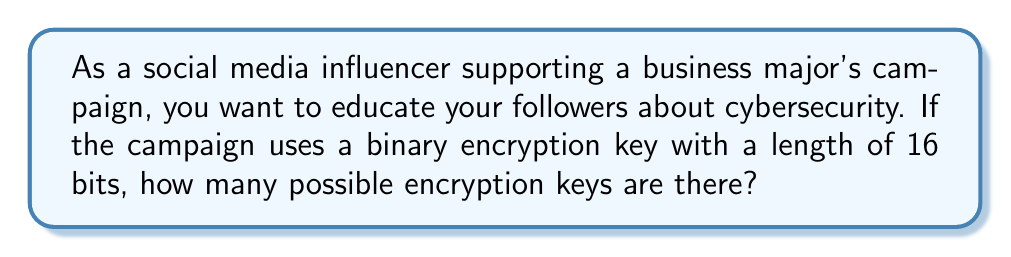Show me your answer to this math problem. To determine the number of possible encryption keys for a given key length, we need to follow these steps:

1. Identify the key length: In this case, it's 16 bits.

2. Understand the possible values for each bit: In binary, each bit can be either 0 or 1.

3. Calculate the total number of possibilities:
   - For each bit, there are 2 choices (0 or 1)
   - We have 16 bits in total
   - The total number of possibilities is given by the formula:

   $$\text{Number of keys} = 2^{\text{key length}}$$

4. Apply the formula:
   $$\text{Number of keys} = 2^{16}$$

5. Calculate the result:
   $$2^{16} = 65,536$$

Therefore, there are 65,536 possible encryption keys for a 16-bit binary key.

This large number of possibilities demonstrates the importance of key length in encryption, which is crucial for maintaining the security of the business campaign's online presence.
Answer: $2^{16} = 65,536$ 